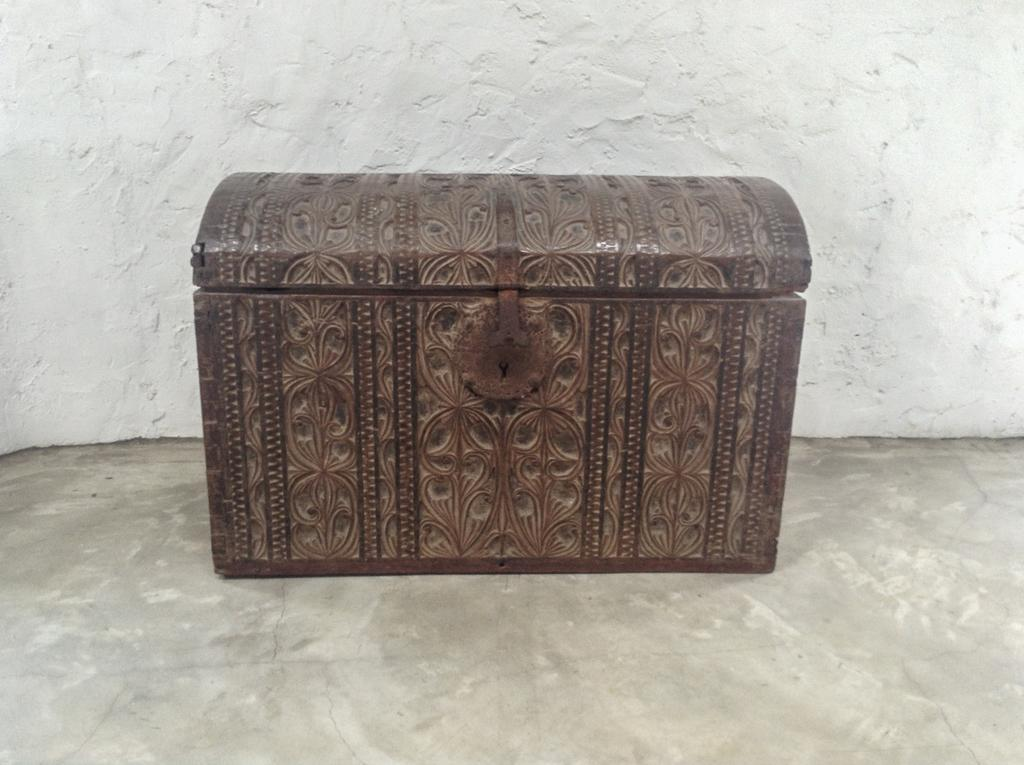What is the main object in the center of the image? There is a trunk box in the center of the image. Where is the trunk box located? The trunk box is placed on the floor. What can be seen in the background of the image? There is a wall in the background of the image. How many pizzas are hanging from the wall in the image? There are no pizzas present in the image; it only features a trunk box on the floor and a wall in the background. 